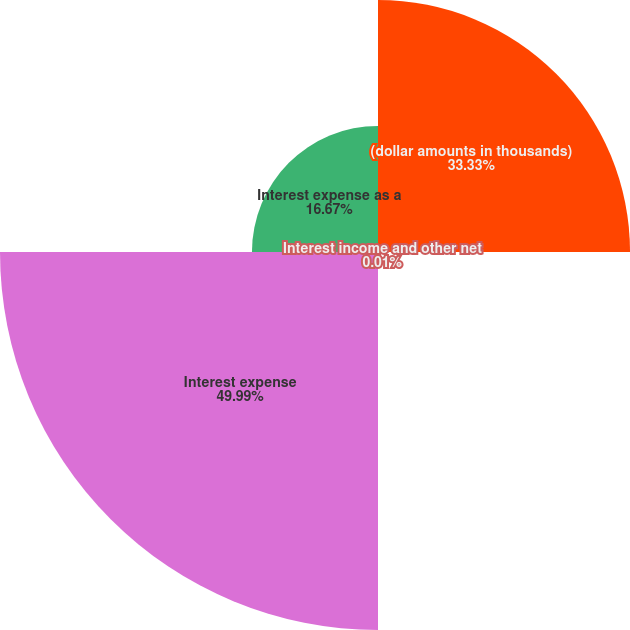Convert chart. <chart><loc_0><loc_0><loc_500><loc_500><pie_chart><fcel>(dollar amounts in thousands)<fcel>Interest income and other net<fcel>Interest expense<fcel>Interest expense as a<nl><fcel>33.33%<fcel>0.01%<fcel>49.99%<fcel>16.67%<nl></chart> 